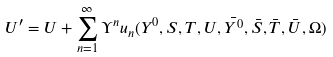<formula> <loc_0><loc_0><loc_500><loc_500>U ^ { \prime } = U + \sum _ { n = 1 } ^ { \infty } \Upsilon ^ { n } u _ { n } ( Y ^ { 0 } , S , T , U , \bar { Y ^ { 0 } } , \bar { S } , \bar { T } , \bar { U } , \Omega )</formula> 